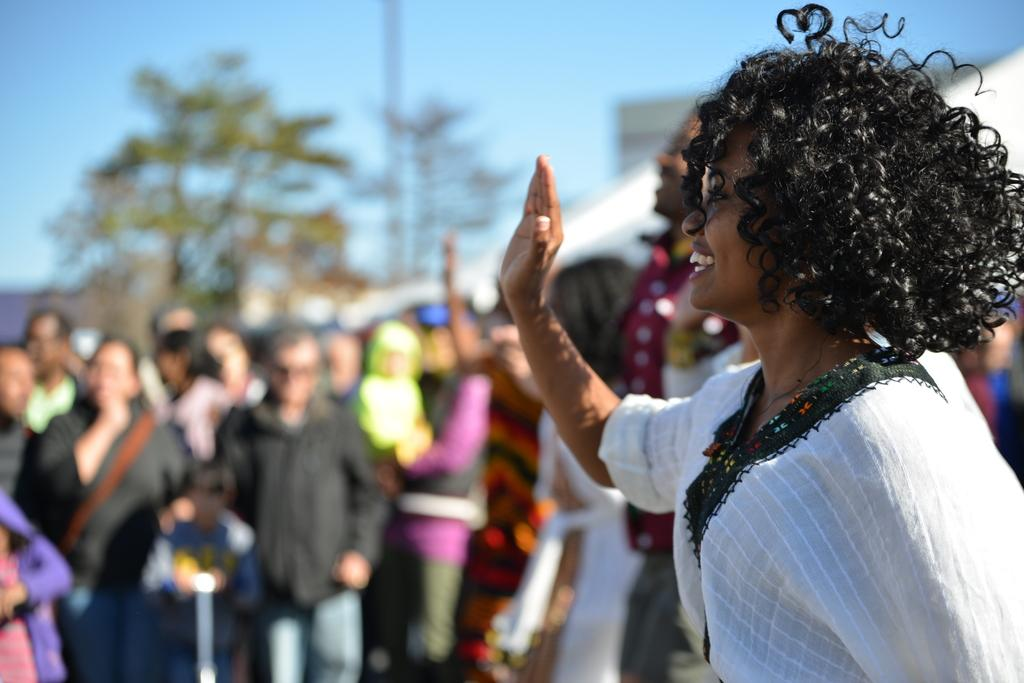Who or what is present in the image? There are people in the image. What is the facial expression of the people in the image? The people are smiling. What can be seen in the background of the image? There are trees and buildings visible in the background of the image. What color is the vest worn by the person in the image? There is no mention of a vest in the image, so we cannot determine its color. 